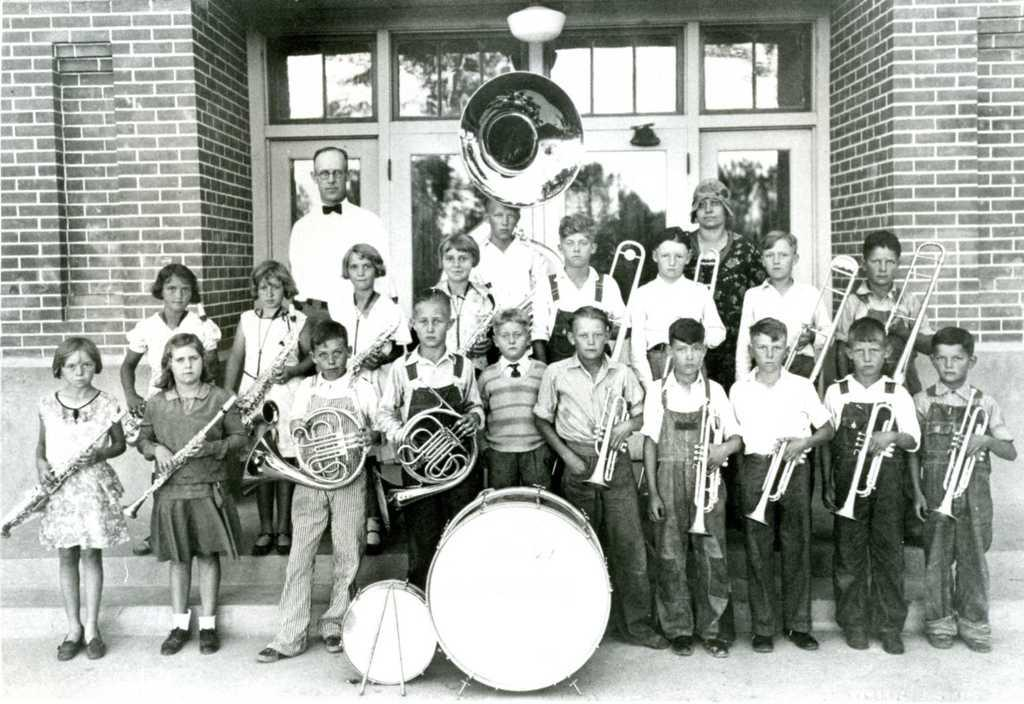Who or what can be seen in the image? There are people in the image. What are the people doing? The people are standing and holding musical instruments. What can be seen in the distance behind the people? There is a building in the background of the image. How many balloons are being held by the people in the image? There are no balloons present in the image; the people are holding musical instruments. Which leg is the person on the left using to play their instrument? The image does not provide enough detail to determine which leg the person on the left is using to play their instrument. 